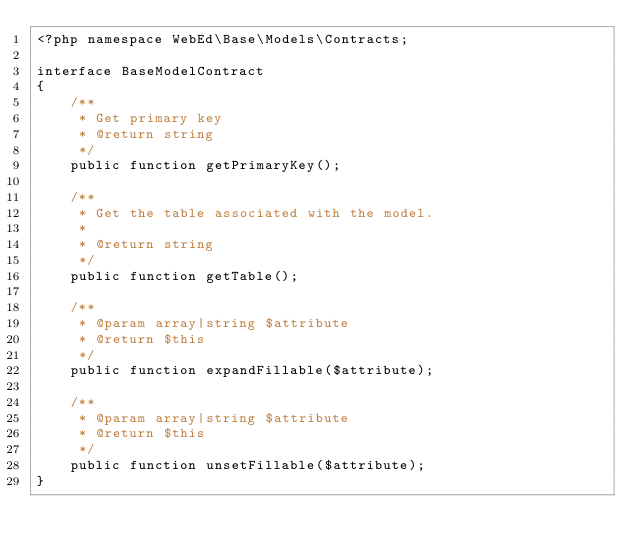Convert code to text. <code><loc_0><loc_0><loc_500><loc_500><_PHP_><?php namespace WebEd\Base\Models\Contracts;

interface BaseModelContract
{
    /**
     * Get primary key
     * @return string
     */
    public function getPrimaryKey();

    /**
     * Get the table associated with the model.
     *
     * @return string
     */
    public function getTable();

    /**
     * @param array|string $attribute
     * @return $this
     */
    public function expandFillable($attribute);

    /**
     * @param array|string $attribute
     * @return $this
     */
    public function unsetFillable($attribute);
}
</code> 